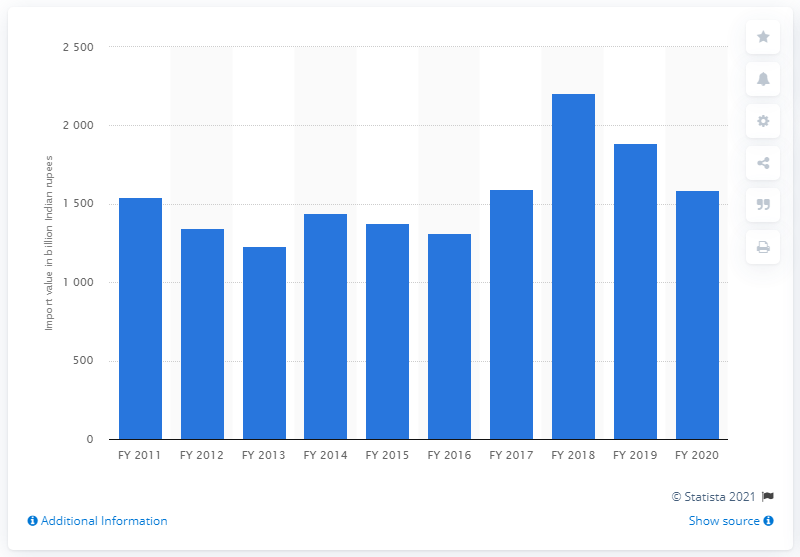List a handful of essential elements in this visual. The value of pearls, precious, and semi-precious stones imported by India in the fiscal year 2018 was 2209.7 million dollars. In the fiscal year 2020, India imported a total of 1590.66 million US dollars worth of pearls, precious and semi-precious stones. 